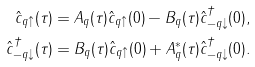<formula> <loc_0><loc_0><loc_500><loc_500>\hat { c } _ { q \uparrow } ( \tau ) & = A _ { q } ( \tau ) \hat { c } _ { q \uparrow } ( 0 ) - B _ { q } ( \tau ) \hat { c } _ { - q \downarrow } ^ { \dagger } ( 0 ) , \\ \hat { c } _ { - q \downarrow } ^ { \dagger } ( \tau ) & = B _ { q } ( \tau ) \hat { c } _ { q \uparrow } ( 0 ) + A _ { q } ^ { \ast } ( \tau ) \hat { c } _ { - q \downarrow } ^ { \dagger } ( 0 ) .</formula> 